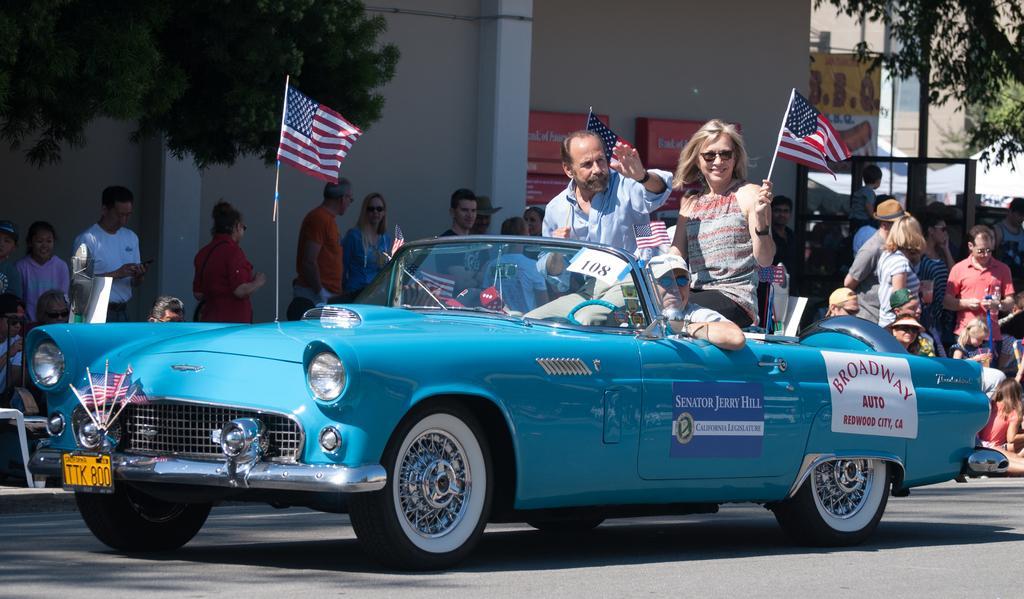How would you summarize this image in a sentence or two? In this image i can see a man and a woman holding flags in their hands sitting in a car, i can see a person sitting in the driving seat. In the background i can see few people standing on the sidewalk, a flag, few trees and few buildings. 